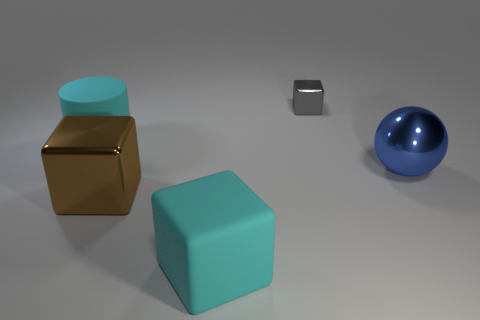Are there any other things that have the same color as the small block?
Your answer should be compact. No. Is the shape of the brown thing the same as the small metal thing to the right of the large cyan block?
Your answer should be compact. Yes. Do the cyan thing that is in front of the cylinder and the ball have the same size?
Give a very brief answer. Yes. What shape is the blue object that is the same size as the rubber cube?
Provide a short and direct response. Sphere. Is the tiny object the same shape as the big brown object?
Offer a very short reply. Yes. What number of matte things have the same shape as the brown metal object?
Provide a short and direct response. 1. How many shiny cubes are behind the cyan rubber block?
Keep it short and to the point. 2. There is a large matte thing in front of the big blue ball; is it the same color as the cylinder?
Your answer should be very brief. Yes. How many brown metal cubes are the same size as the blue object?
Give a very brief answer. 1. There is a big blue object that is the same material as the brown block; what shape is it?
Provide a short and direct response. Sphere. 